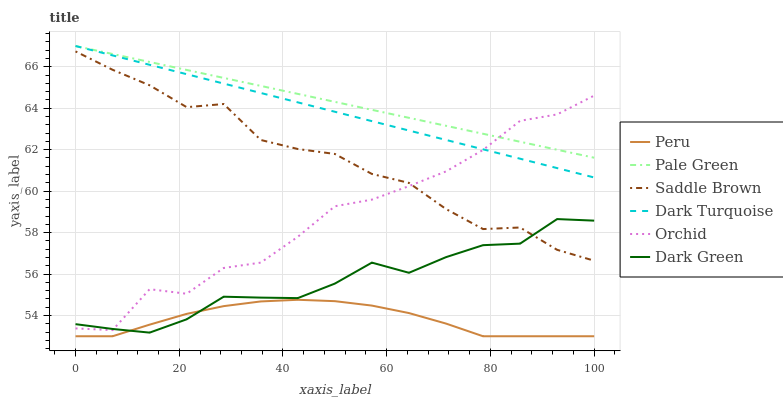Does Peru have the minimum area under the curve?
Answer yes or no. Yes. Does Pale Green have the maximum area under the curve?
Answer yes or no. Yes. Does Pale Green have the minimum area under the curve?
Answer yes or no. No. Does Peru have the maximum area under the curve?
Answer yes or no. No. Is Pale Green the smoothest?
Answer yes or no. Yes. Is Orchid the roughest?
Answer yes or no. Yes. Is Peru the smoothest?
Answer yes or no. No. Is Peru the roughest?
Answer yes or no. No. Does Peru have the lowest value?
Answer yes or no. Yes. Does Pale Green have the lowest value?
Answer yes or no. No. Does Pale Green have the highest value?
Answer yes or no. Yes. Does Peru have the highest value?
Answer yes or no. No. Is Peru less than Saddle Brown?
Answer yes or no. Yes. Is Pale Green greater than Dark Green?
Answer yes or no. Yes. Does Dark Turquoise intersect Pale Green?
Answer yes or no. Yes. Is Dark Turquoise less than Pale Green?
Answer yes or no. No. Is Dark Turquoise greater than Pale Green?
Answer yes or no. No. Does Peru intersect Saddle Brown?
Answer yes or no. No. 